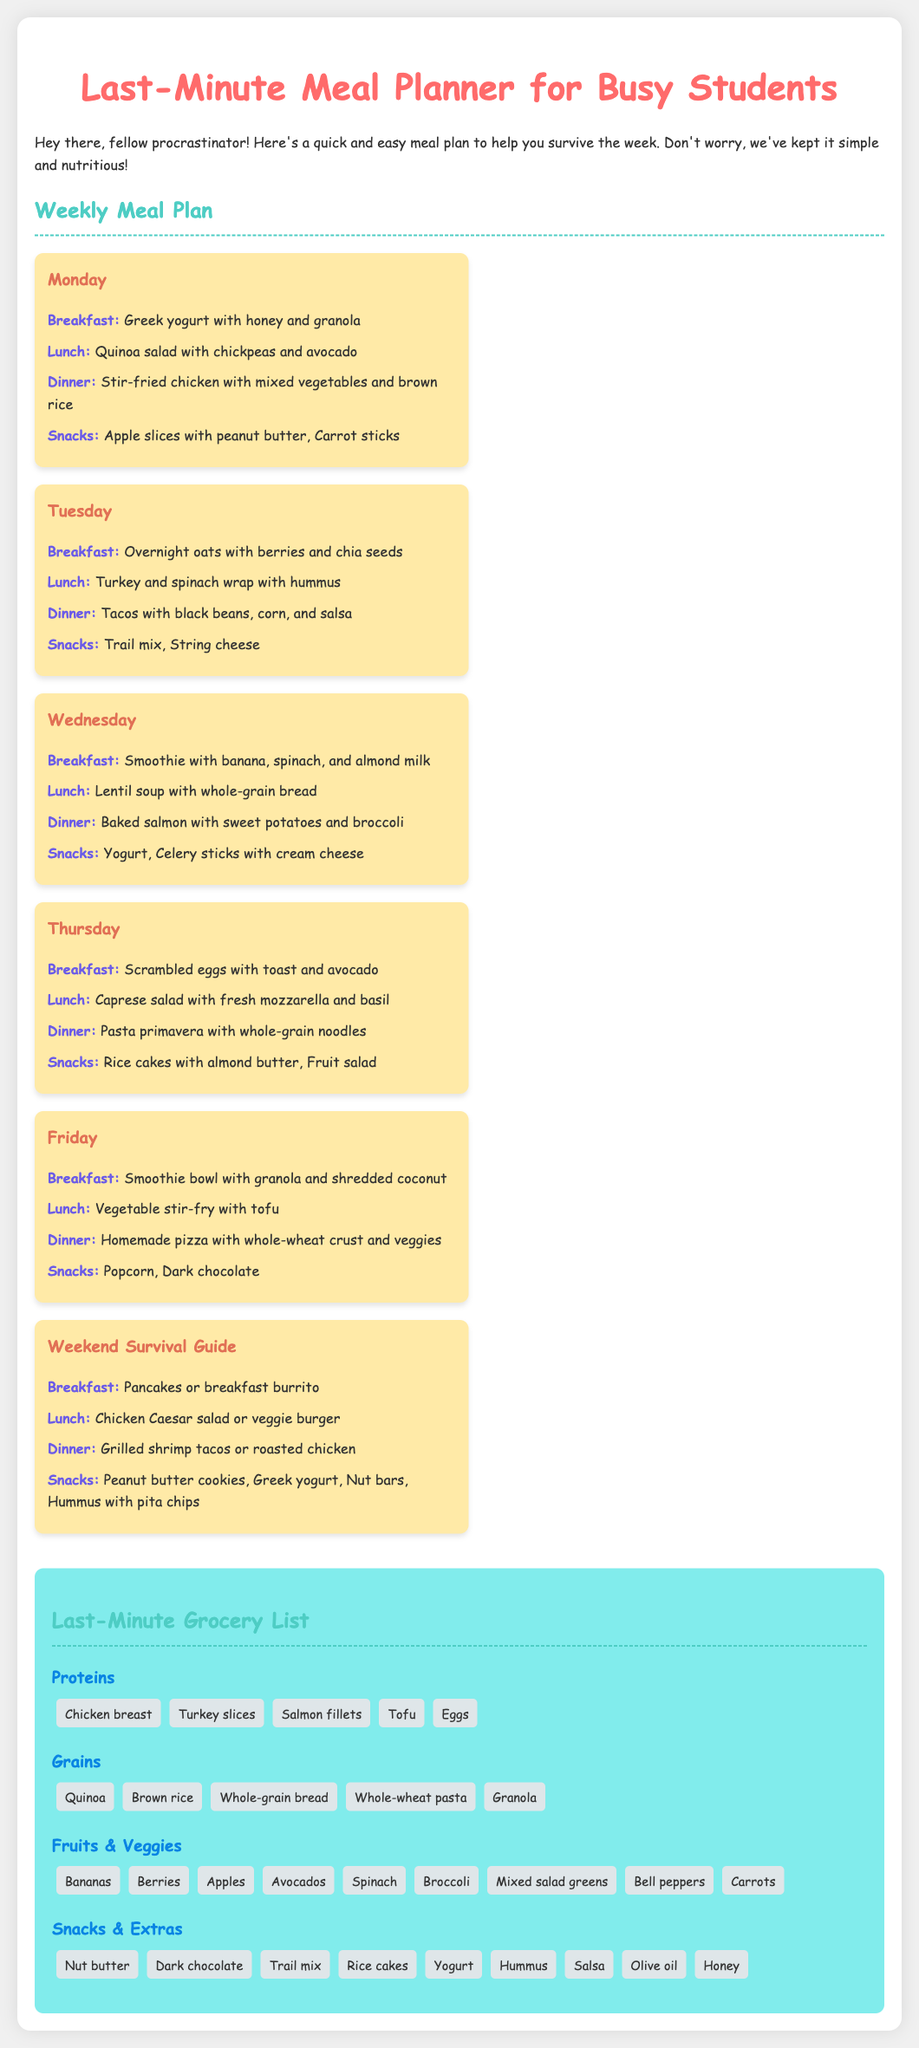What is the title of the document? The title of the document is indicated at the top of the page.
Answer: Last-Minute Meal Planner for Busy Students What week is the meal plan designed for? The meal plan is designed for a week, specifically starting from Monday to the weekend.
Answer: Weekly What type of yogurt is suggested for breakfast on Monday? The specific type of yogurt is mentioned in the breakfast section for Monday.
Answer: Greek yogurt Which meal includes black beans? The meal that includes black beans is found in the dinner section for Tuesday.
Answer: Dinner What is listed as a snack option for Friday? Snack options can be found in the Friday section, which is explicitly mentioned.
Answer: Popcorn How many types of proteins are suggested in the grocery list? The number of protein types can be calculated from the proteins listed in the grocery section.
Answer: Five What meal is recommended on Wednesday for lunch? The lunch recommendation for Wednesday is specified clearly in the plan.
Answer: Lentil soup with whole-grain bread What is a common vegetable included in the meal plan? Vegetables are mentioned throughout the meal plan, and specific examples can be found in various meals.
Answer: Spinach What is the background color of the grocery list section? The document describes the grocery list section's background color in its styles.
Answer: Light blue 